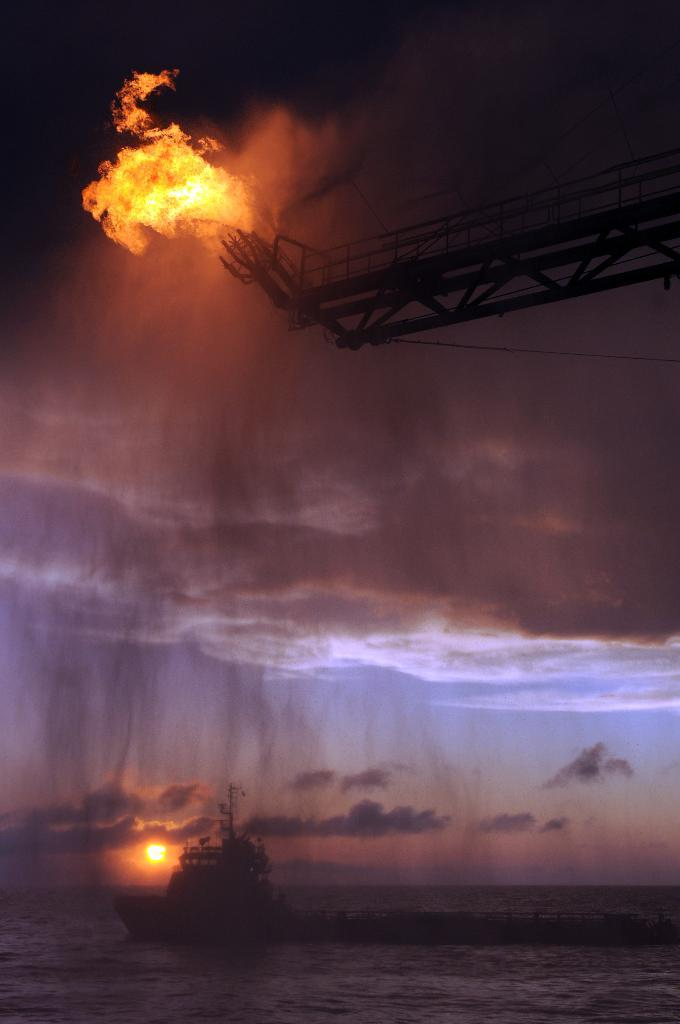What is the main setting of the image? The main setting of the image is an ocean. What can be seen in the ocean? There is a ship in the ocean. What is visible in the sky in the background? A: There is a sun and clouds in the sky in the background. What is the source of fire in the image? There is a stand at the top of the image from which a fire is produced. What type of vacation is being offered by the ship in the image? The image does not provide any information about a vacation being offered by the ship. What surprise can be seen on the ship in the image? There is no surprise visible on the ship in the image. 